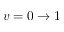<formula> <loc_0><loc_0><loc_500><loc_500>v = 0 \to 1</formula> 